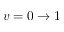<formula> <loc_0><loc_0><loc_500><loc_500>v = 0 \to 1</formula> 